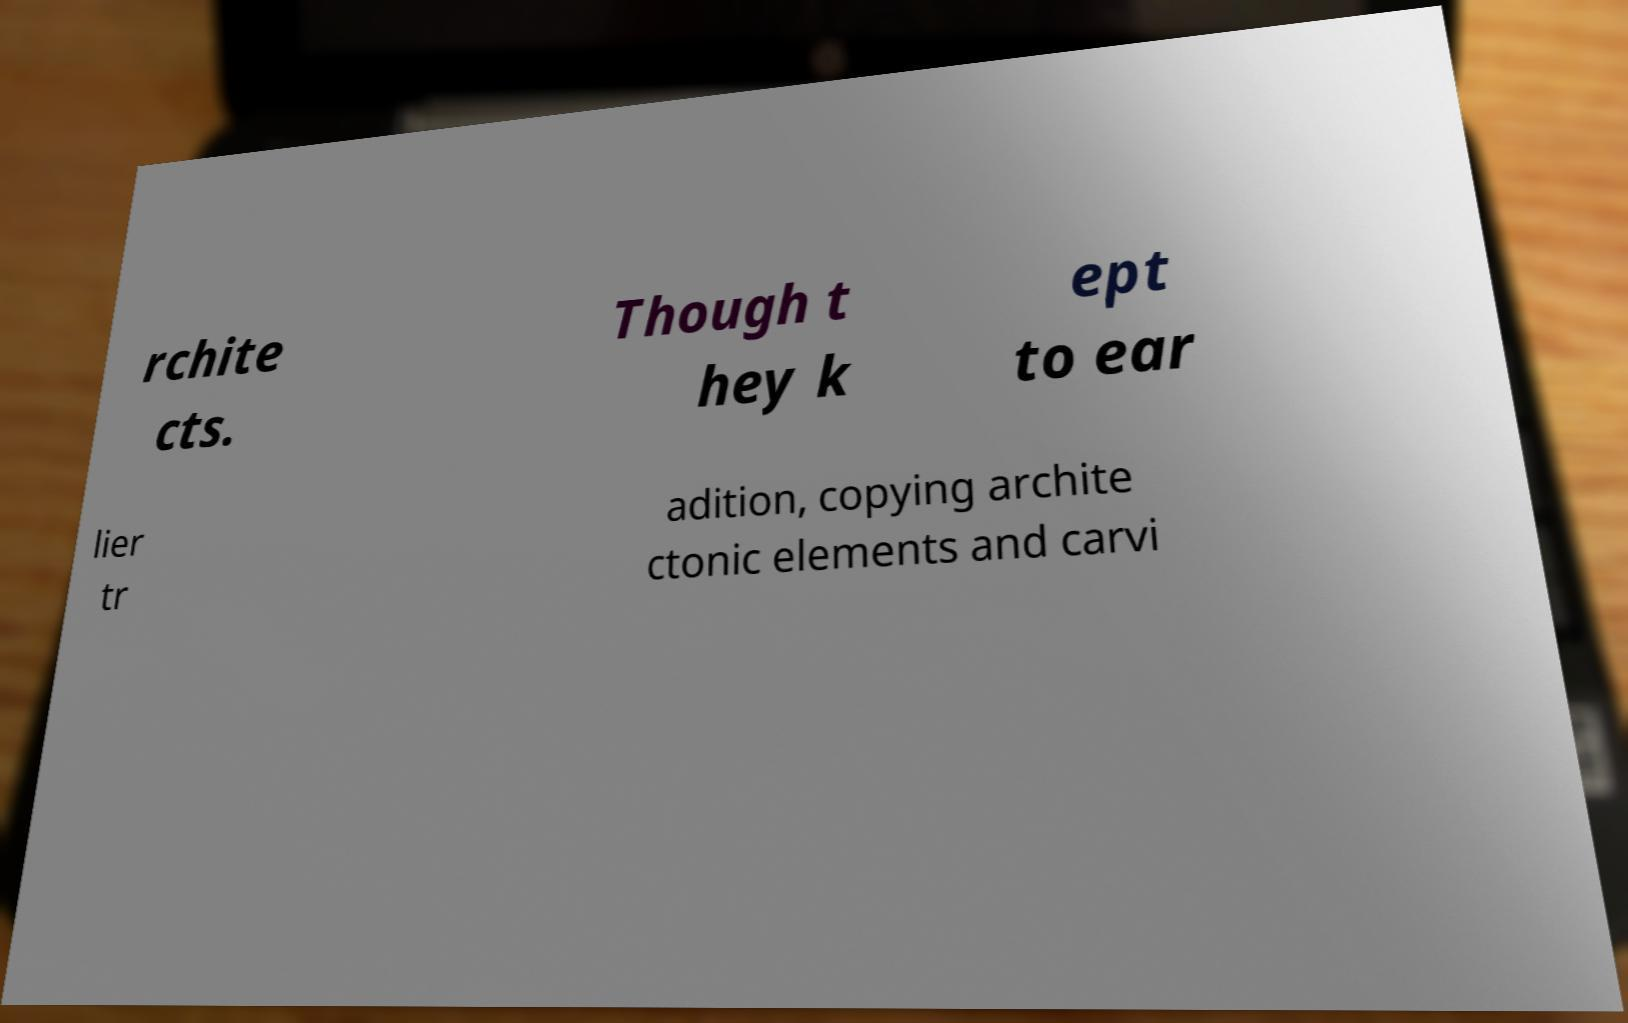Could you extract and type out the text from this image? rchite cts. Though t hey k ept to ear lier tr adition, copying archite ctonic elements and carvi 